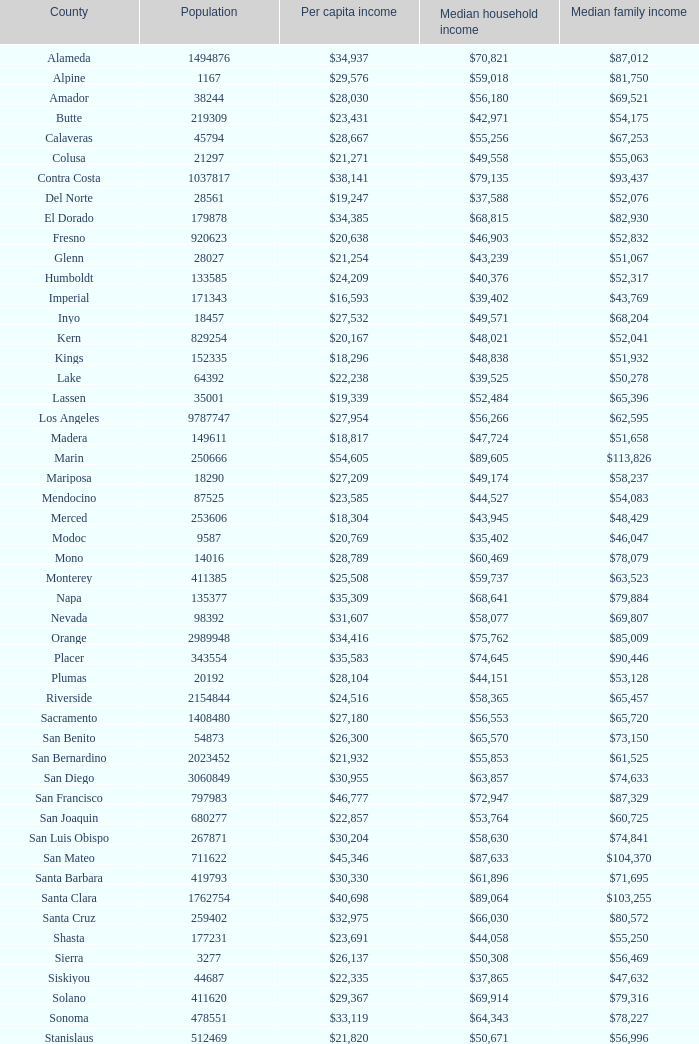What is the average income per individual in shasta? $23,691. 